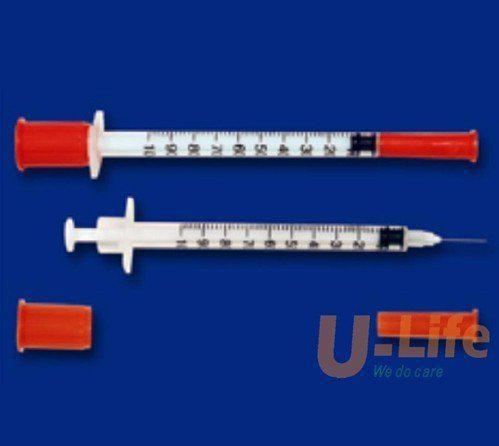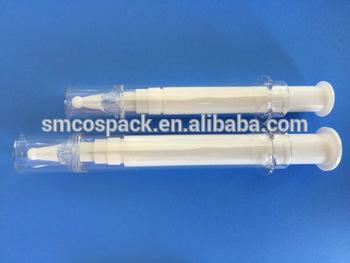The first image is the image on the left, the second image is the image on the right. Examine the images to the left and right. Is the description "At least one orange cap is visible in the image on the left." accurate? Answer yes or no. Yes. 